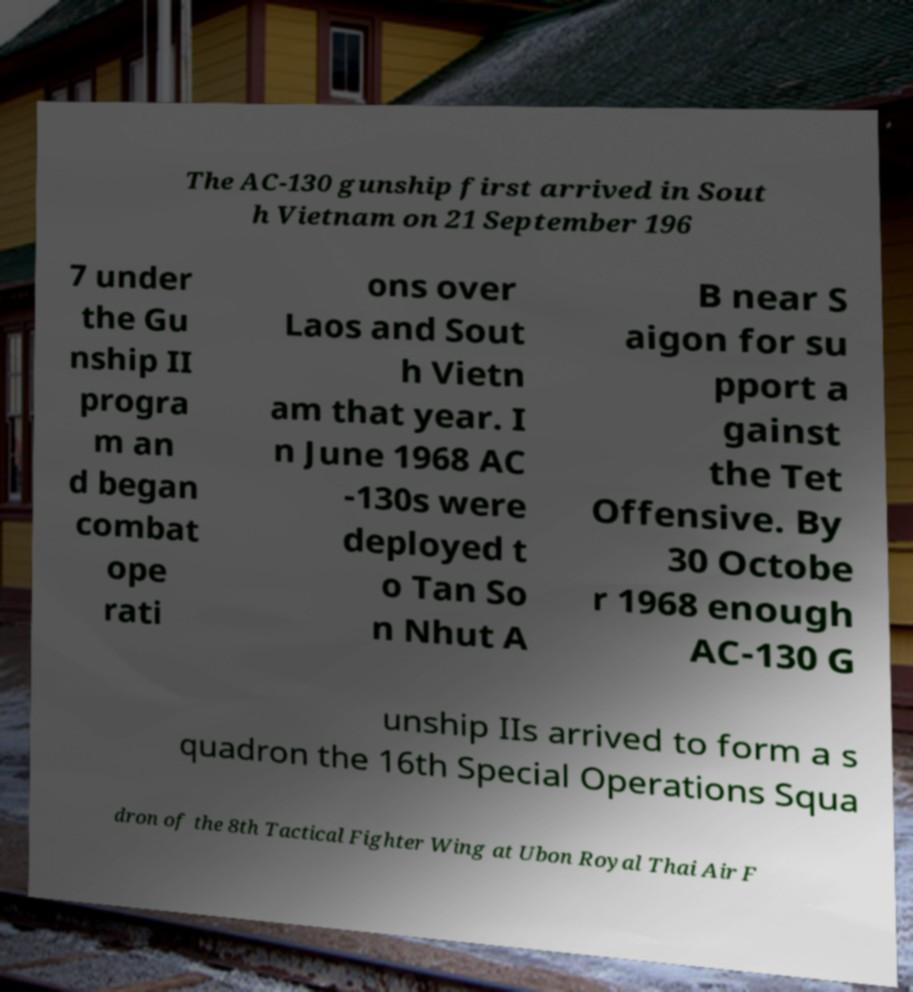Can you read and provide the text displayed in the image?This photo seems to have some interesting text. Can you extract and type it out for me? The AC-130 gunship first arrived in Sout h Vietnam on 21 September 196 7 under the Gu nship II progra m an d began combat ope rati ons over Laos and Sout h Vietn am that year. I n June 1968 AC -130s were deployed t o Tan So n Nhut A B near S aigon for su pport a gainst the Tet Offensive. By 30 Octobe r 1968 enough AC-130 G unship IIs arrived to form a s quadron the 16th Special Operations Squa dron of the 8th Tactical Fighter Wing at Ubon Royal Thai Air F 